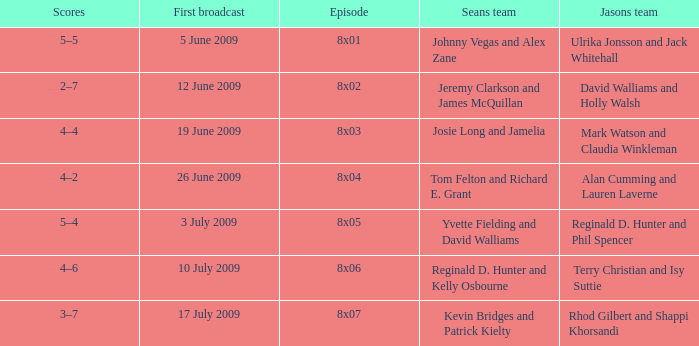What is the broadcast date where Jason's team is Rhod Gilbert and Shappi Khorsandi? 17 July 2009. 